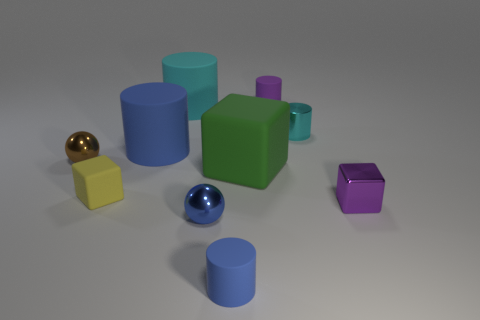There is a tiny purple thing that is the same shape as the large blue rubber thing; what material is it? The tiny purple object, which shares the same cylindrical shape as the larger blue object, is also made of rubber. This is suggested by its matte surface and the way it interacts with light, which is similar to the blue object commonly known to be made of rubber. 